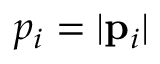<formula> <loc_0><loc_0><loc_500><loc_500>p _ { i } = | { p } _ { i } |</formula> 